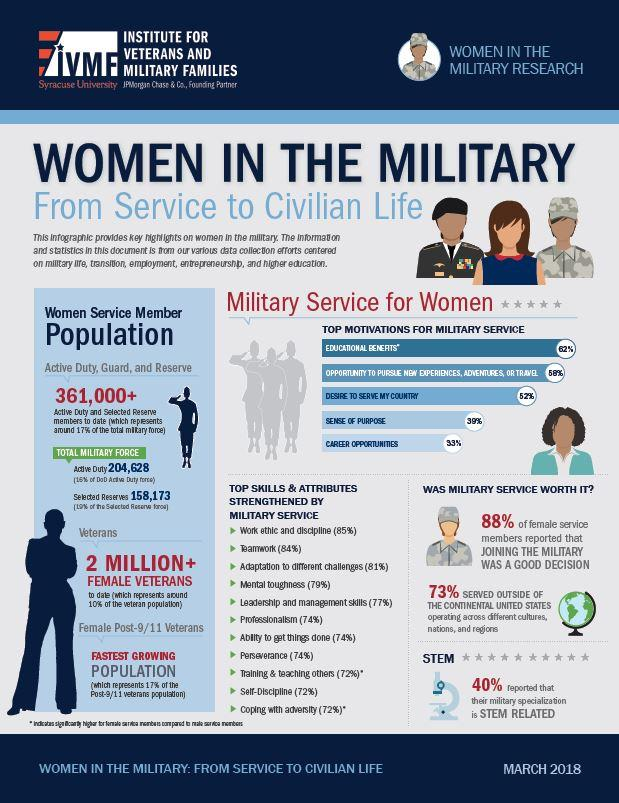Outline some significant characteristics in this image. According to data, 73% of women serving in militias served in locations outside of the United States. According to a recent study, 72% of women have reported improvement in their abilities in training, discipline, and facing challenges while serving in the army. 